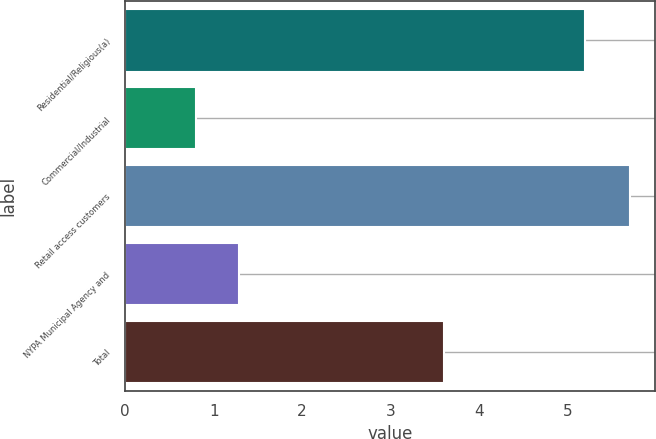Convert chart. <chart><loc_0><loc_0><loc_500><loc_500><bar_chart><fcel>Residential/Religious(a)<fcel>Commercial/Industrial<fcel>Retail access customers<fcel>NYPA Municipal Agency and<fcel>Total<nl><fcel>5.2<fcel>0.8<fcel>5.7<fcel>1.29<fcel>3.6<nl></chart> 